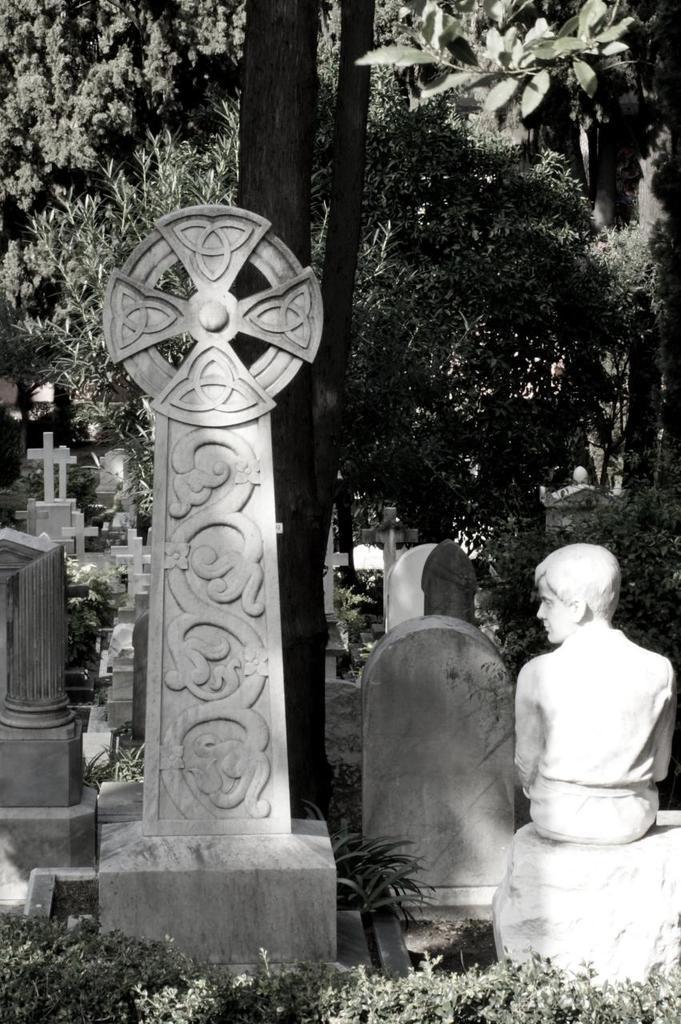Can you describe this image briefly? In this picture we can see some graves and a memorial, in the background there are some trees, we can see Christianity symbols here. 